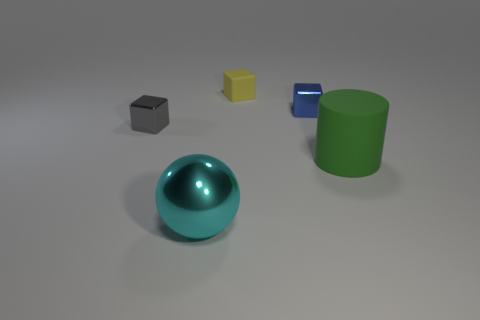Add 1 big green things. How many objects exist? 6 Subtract all metallic blocks. How many blocks are left? 1 Subtract 3 blocks. How many blocks are left? 0 Add 1 matte cylinders. How many matte cylinders exist? 2 Subtract all blue cubes. How many cubes are left? 2 Subtract 0 red cylinders. How many objects are left? 5 Subtract all balls. How many objects are left? 4 Subtract all cyan cubes. Subtract all cyan cylinders. How many cubes are left? 3 Subtract all red spheres. How many purple blocks are left? 0 Subtract all purple metallic cylinders. Subtract all big objects. How many objects are left? 3 